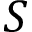Convert formula to latex. <formula><loc_0><loc_0><loc_500><loc_500>S</formula> 